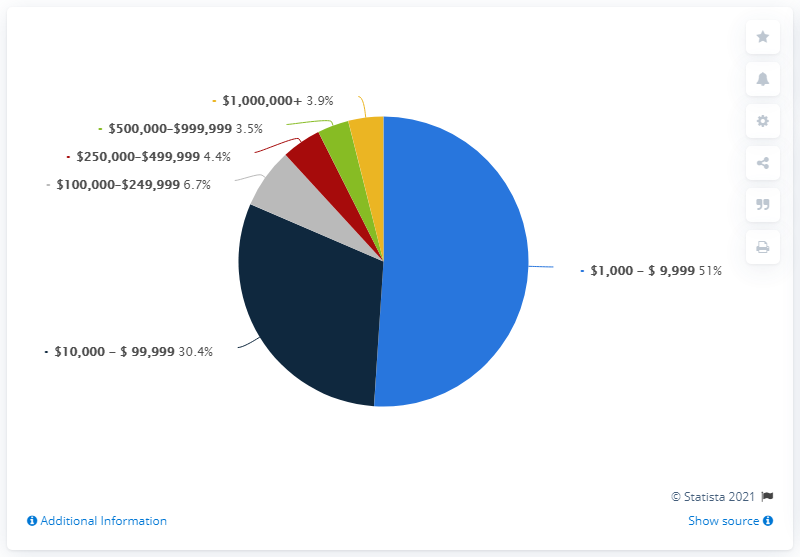Indicate a few pertinent items in this graphic. In 2020, approximately 6.7% of U.S. farms were classified in the sales class between 100,000 and 249,999 U.S. dollars. The category with the highest value is $1,000 to $9,999. The sum of the least four values is 18.5. 